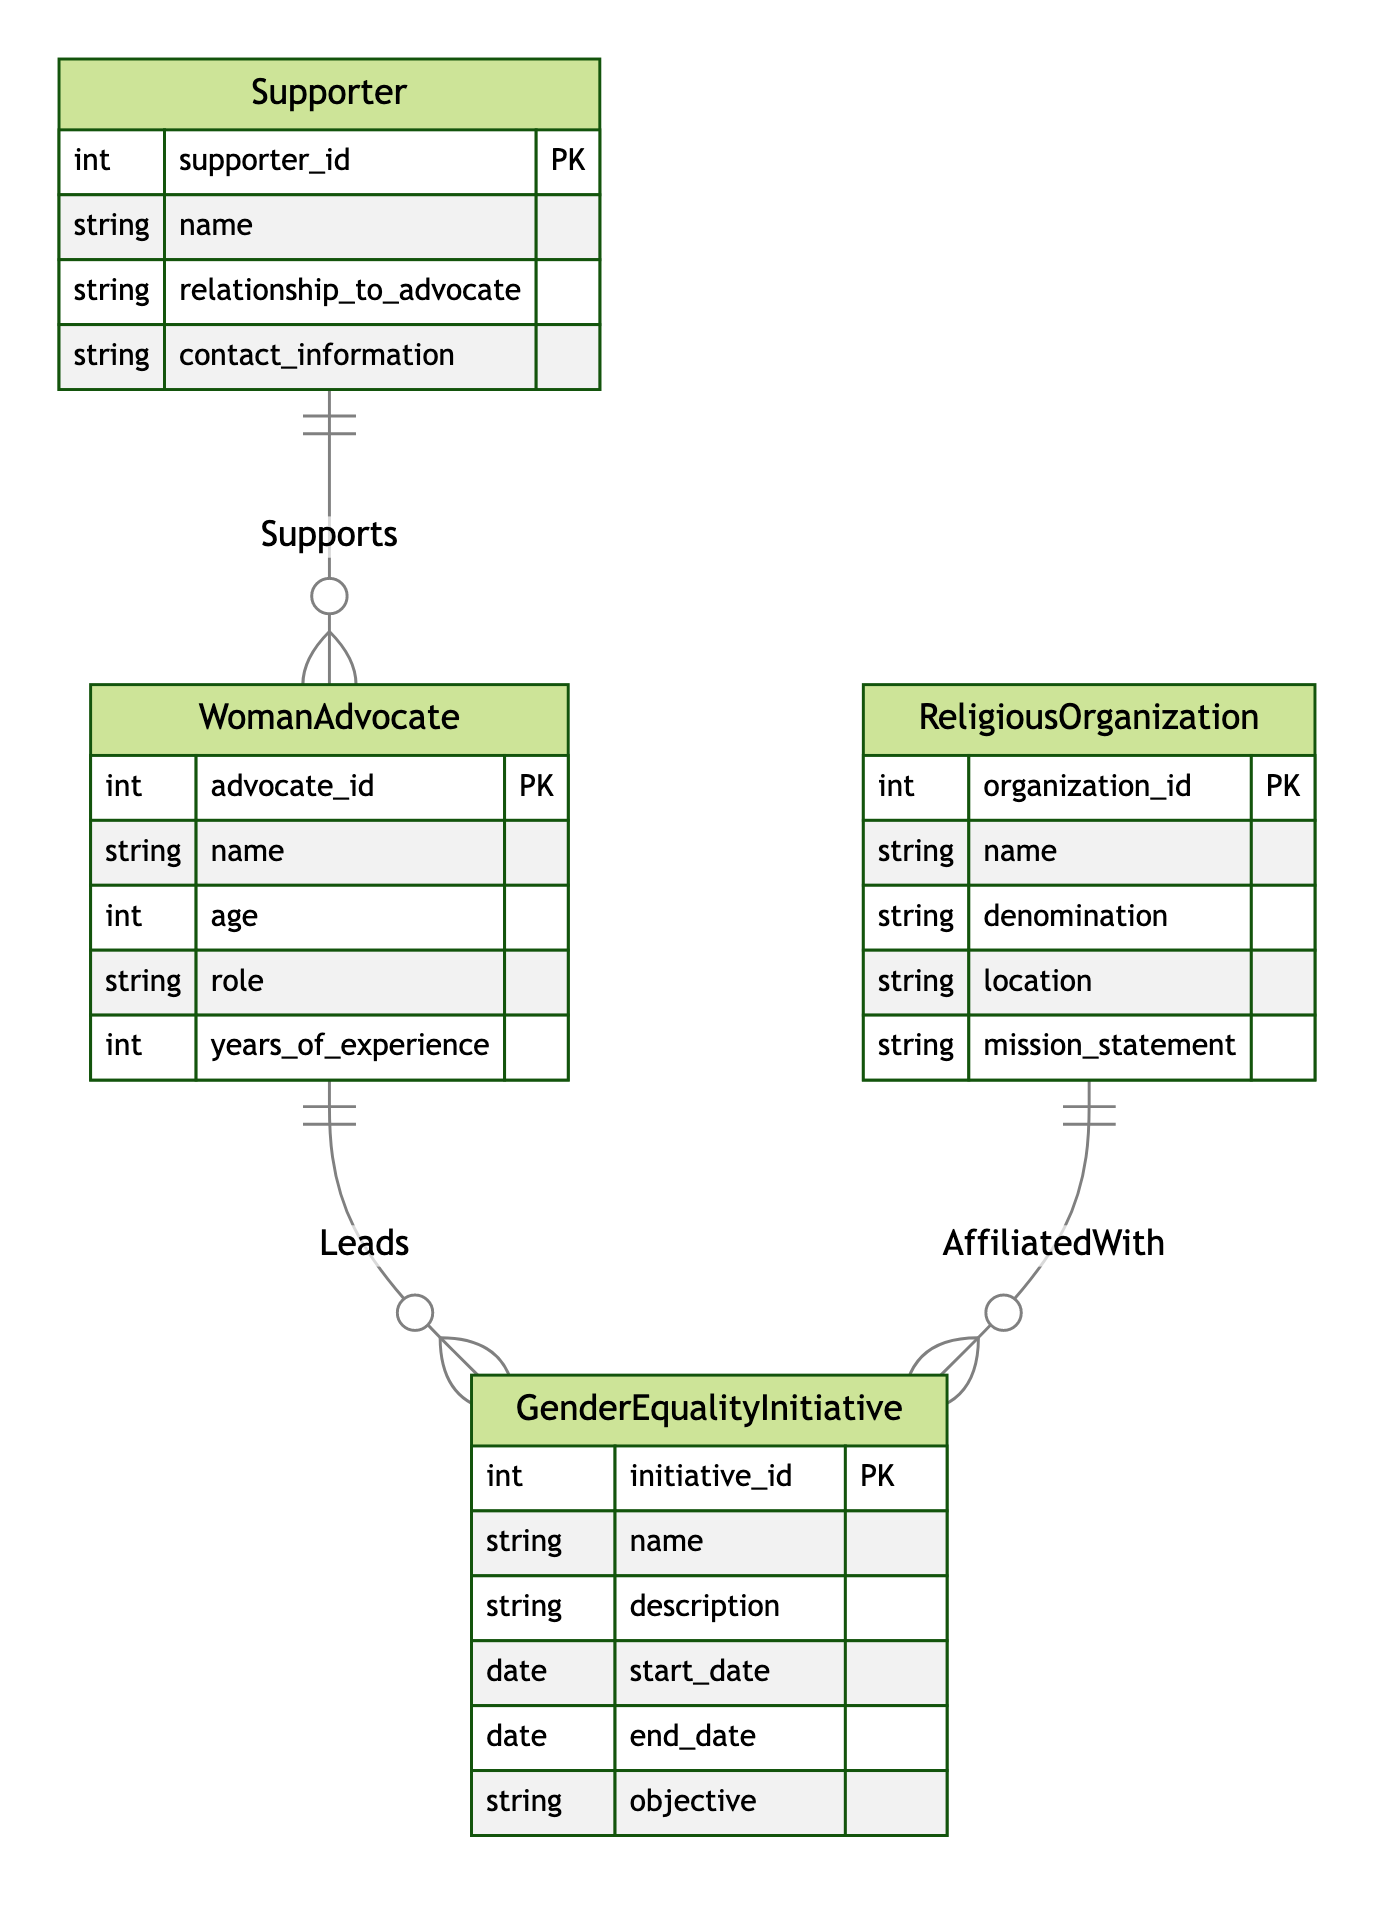What entities are present in the diagram? The diagram includes four entities: WomanAdvocate, ReligiousOrganization, GenderEqualityInitiative, and Supporter.
Answer: WomanAdvocate, ReligiousOrganization, GenderEqualityInitiative, Supporter How many attributes does the WomanAdvocate entity have? The WomanAdvocate entity has five attributes: advocate_id, name, age, role, and years_of_experience.
Answer: 5 What is the relationship type between WomanAdvocate and GenderEqualityInitiative? The relationship type between WomanAdvocate and GenderEqualityInitiative is "Leads", indicating that a woman advocate leads an initiative.
Answer: Leads Which entity is affiliated with GenderEqualityInitiative? The ReligiousOrganization is affiliated with the GenderEqualityInitiative, as per the relationship "AffiliatedWith".
Answer: ReligiousOrganization How many relationships are present in the diagram? There are three relationships present: Leads, AffiliatedWith, and Supports.
Answer: 3 Which entity does the Supporter relate to? The Supporter entity relates to the WomanAdvocate entity through the "Supports" relationship.
Answer: WomanAdvocate What is the primary key of the GenderEqualityInitiative entity? The primary key of the GenderEqualityInitiative entity is initiative_id.
Answer: initiative_id Can a WomanAdvocate have multiple Supporters? Yes, a WomanAdvocate can have multiple Supporters based on the one-to-many relationship shown in the diagram.
Answer: Yes What type of initiative is managed by a WomanAdvocate? The initiative managed by a WomanAdvocate is called a GenderEqualityInitiative.
Answer: GenderEqualityInitiative 